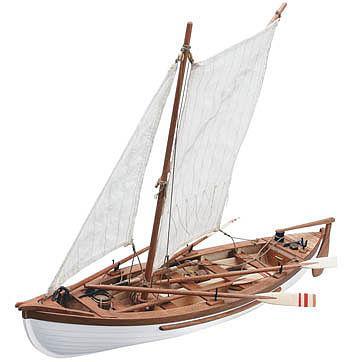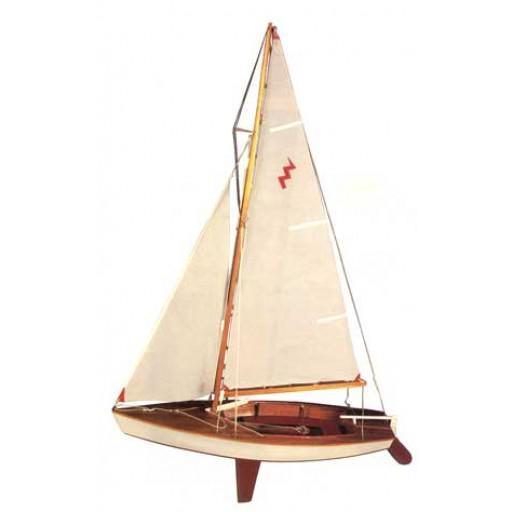The first image is the image on the left, the second image is the image on the right. Examine the images to the left and right. Is the description "The left and right images feature the same type of boat model, but the boat on the left has no upright dowel mast, and the boat on the right has an upright mast." accurate? Answer yes or no. No. The first image is the image on the left, the second image is the image on the right. Assess this claim about the two images: "Both boats have unfurled sails.". Correct or not? Answer yes or no. Yes. 